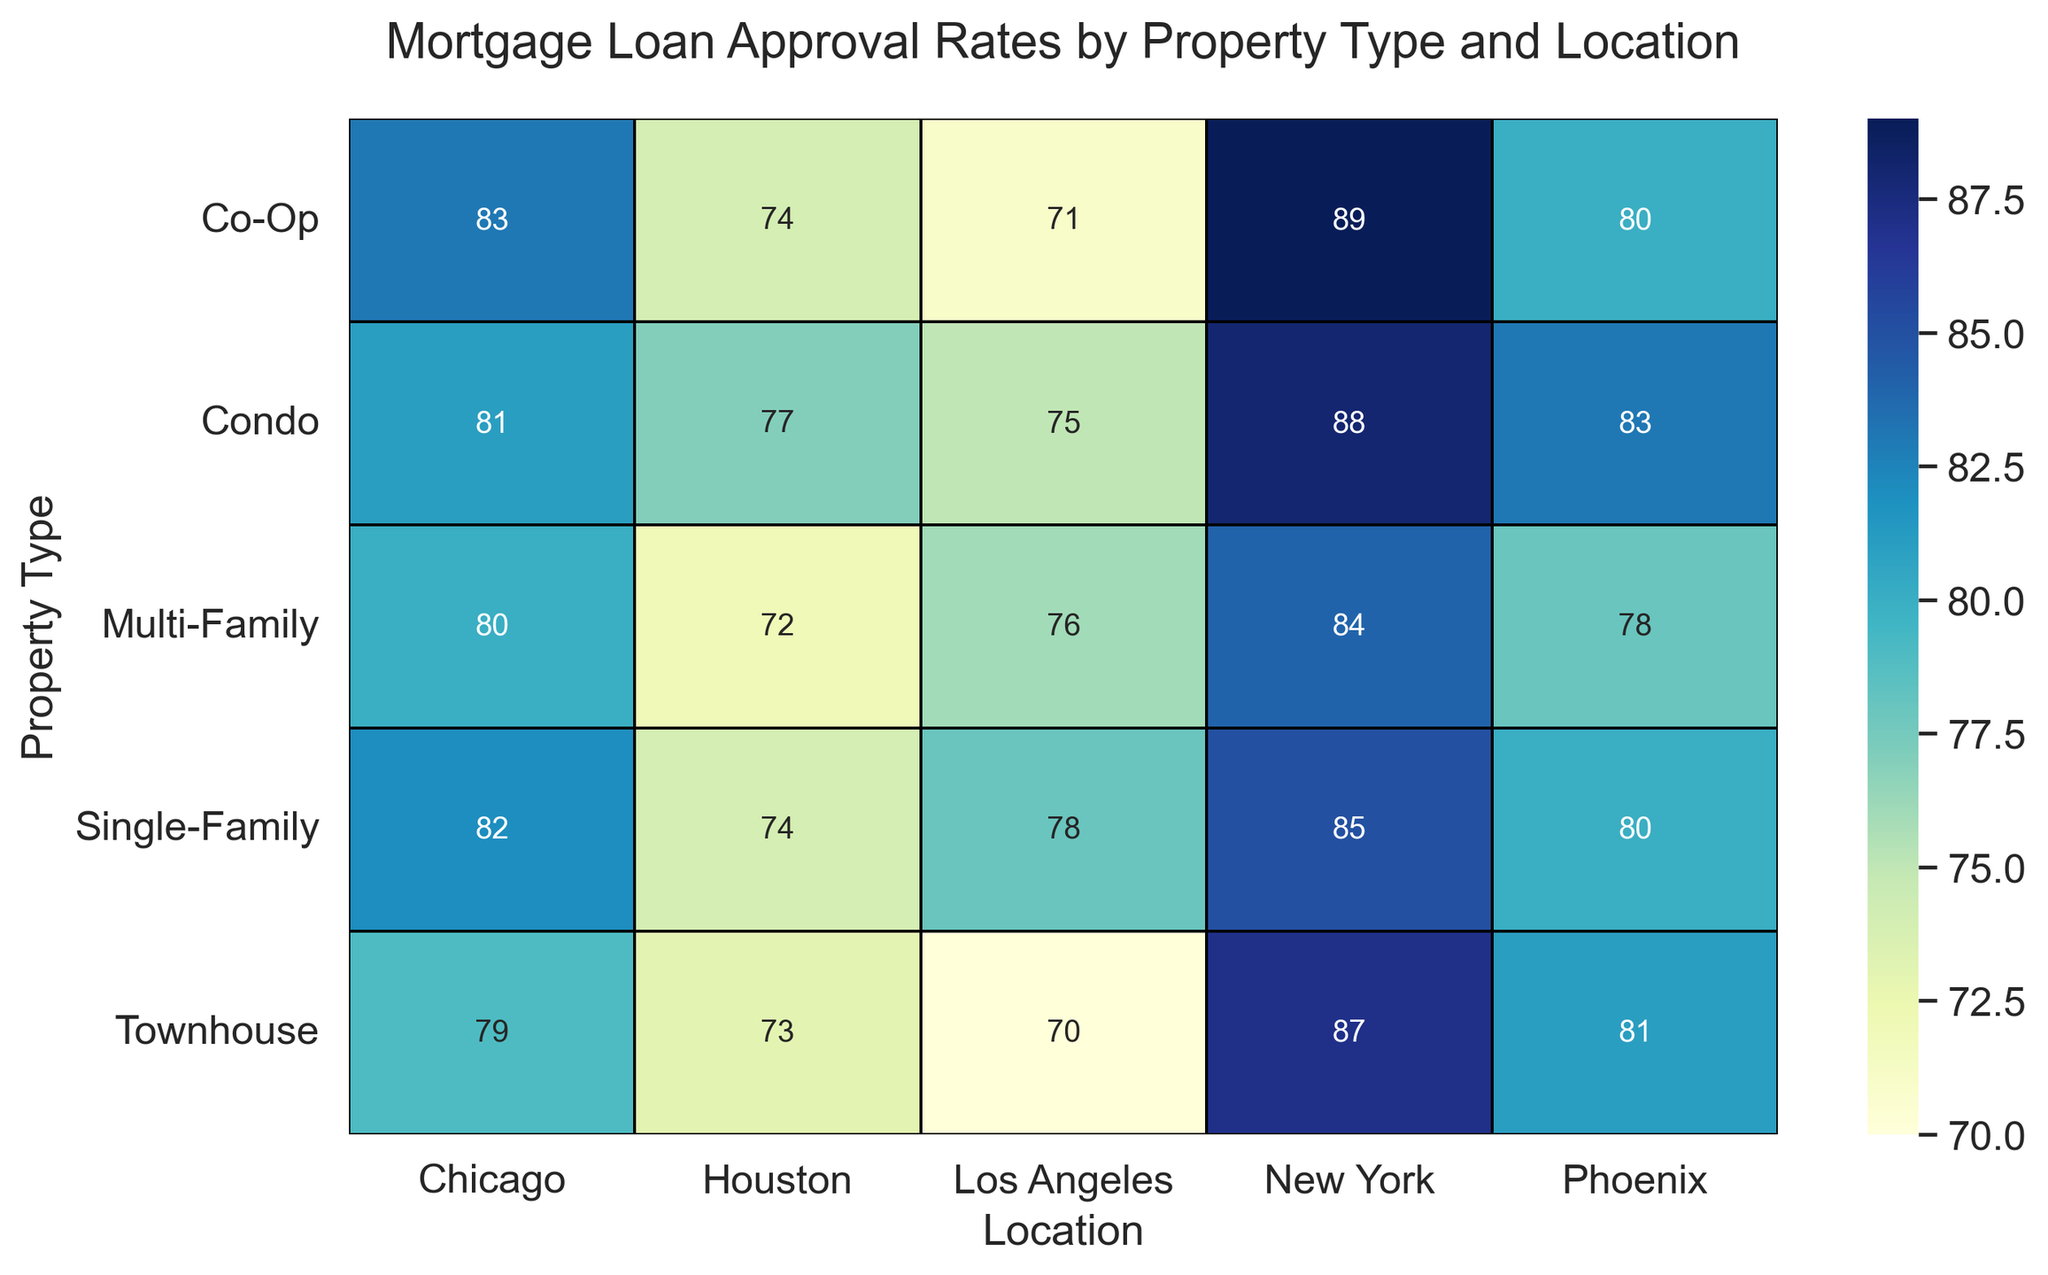What property type has the highest mortgage loan approval rate in Phoenix? Look at the "Phoenix" column and find the highest number. The highest value is 83 for Condo.
Answer: Condo Which location has the lowest approval rate for Townhouses? Look at the "Townhouse" row and find the smallest number. The lowest value is 70 for Los Angeles.
Answer: Los Angeles What is the difference between the mortgage loan approval rates for Condos in New York and Los Angeles? Find the approval rates of Condos in New York (88) and Los Angeles (75). The difference is 88 - 75 = 13.
Answer: 13 Comparing Single-Family and Multi-Family properties, which has the higher overall approval rate across all locations? Sum the approval rates: Single-Family (85 + 78 + 82 + 74 + 80 = 399), Multi-Family (84 + 76 + 80 + 72 + 78 = 390). Single-Family has a higher overall approval rate.
Answer: Single-Family Which property type in Houston has the second lowest approval rate? List the values: Single-Family (74), Condo (77), Townhouse (73), Multi-Family (72), Co-Op (74). The second lowest is 73 for Townhouse.
Answer: Townhouse How many property types have approval rates higher than 80% in Chicago? Look at the "Chicago" column and count values greater than 80: Single-Family (82), Condo (81), Co-Op (83). There are 3 property types.
Answer: 3 Which location has a more varied mortgage approval rate range for Co-Ops and Condos? Observe the difference between the highest and lowest values: Co-Op (Range = 89 - 71 = 18), Condo (Range = 88 - 75 = 13). Co-Op has a more varied range.
Answer: Co-Op For properties in New York, what is the average mortgage loan approval rate across all property types? Sum the approval rates for New York (85 + 88 + 87 + 84 + 89 = 433). Divide by 5 property types. The average is 433 / 5 = 86.6.
Answer: 86.6 In Los Angeles, which property type has an approval rate closest to the average approval rate in the city? Calculate the average for Los Angeles (78 + 75 + 70 + 76 + 71 = 370)/5 = 74. Check nearest value: Condo (75).
Answer: Condo 